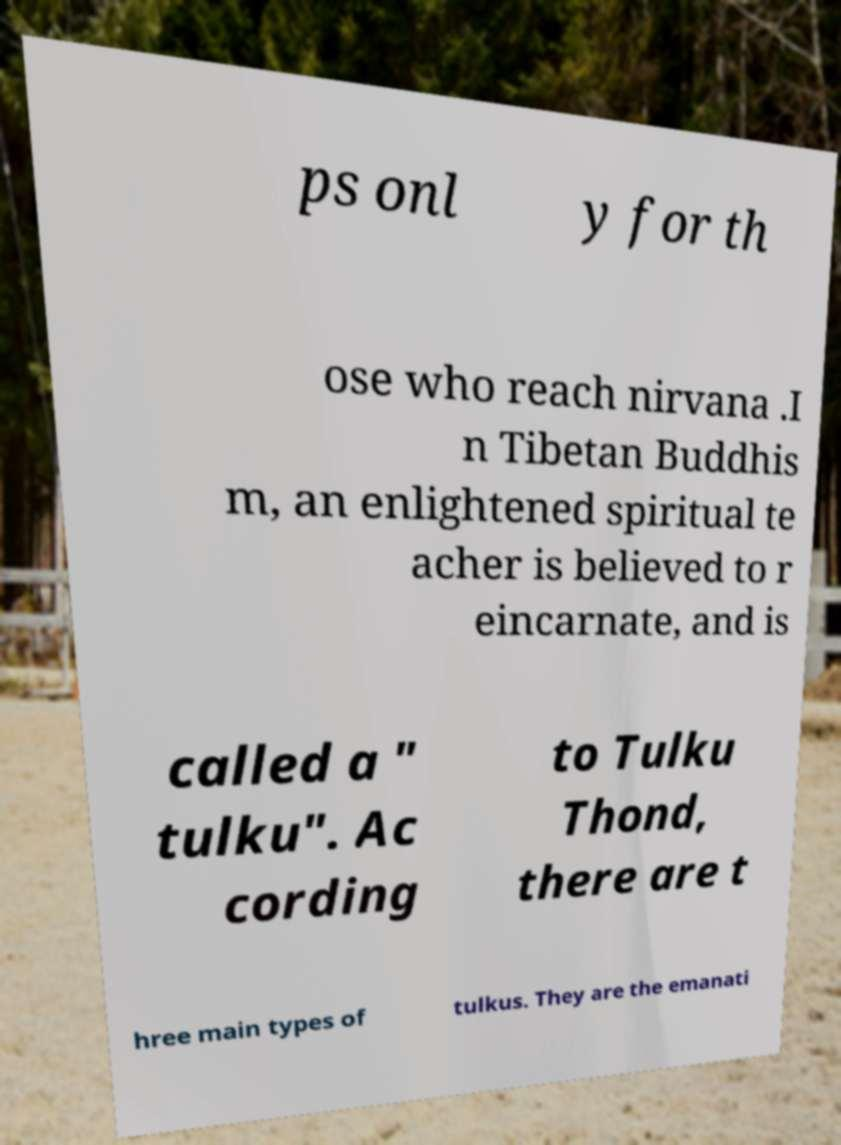I need the written content from this picture converted into text. Can you do that? ps onl y for th ose who reach nirvana .I n Tibetan Buddhis m, an enlightened spiritual te acher is believed to r eincarnate, and is called a " tulku". Ac cording to Tulku Thond, there are t hree main types of tulkus. They are the emanati 